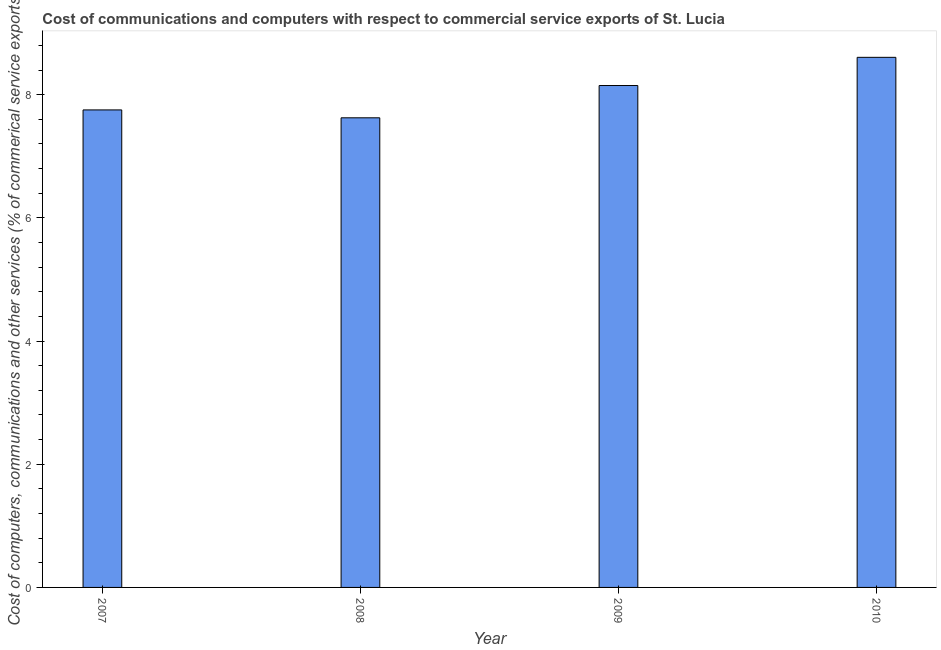What is the title of the graph?
Your answer should be very brief. Cost of communications and computers with respect to commercial service exports of St. Lucia. What is the label or title of the Y-axis?
Keep it short and to the point. Cost of computers, communications and other services (% of commerical service exports). What is the  computer and other services in 2008?
Your response must be concise. 7.63. Across all years, what is the maximum cost of communications?
Offer a terse response. 8.61. Across all years, what is the minimum  computer and other services?
Provide a short and direct response. 7.63. What is the sum of the  computer and other services?
Ensure brevity in your answer.  32.13. What is the difference between the cost of communications in 2008 and 2010?
Make the answer very short. -0.98. What is the average cost of communications per year?
Your answer should be compact. 8.03. What is the median cost of communications?
Make the answer very short. 7.95. In how many years, is the cost of communications greater than 3.6 %?
Keep it short and to the point. 4. What is the difference between the highest and the second highest cost of communications?
Offer a terse response. 0.46. In how many years, is the cost of communications greater than the average cost of communications taken over all years?
Ensure brevity in your answer.  2. How many bars are there?
Make the answer very short. 4. Are all the bars in the graph horizontal?
Ensure brevity in your answer.  No. What is the difference between two consecutive major ticks on the Y-axis?
Offer a terse response. 2. What is the Cost of computers, communications and other services (% of commerical service exports) of 2007?
Your response must be concise. 7.75. What is the Cost of computers, communications and other services (% of commerical service exports) in 2008?
Keep it short and to the point. 7.63. What is the Cost of computers, communications and other services (% of commerical service exports) in 2009?
Offer a terse response. 8.15. What is the Cost of computers, communications and other services (% of commerical service exports) of 2010?
Your answer should be compact. 8.61. What is the difference between the Cost of computers, communications and other services (% of commerical service exports) in 2007 and 2008?
Offer a very short reply. 0.13. What is the difference between the Cost of computers, communications and other services (% of commerical service exports) in 2007 and 2009?
Offer a very short reply. -0.4. What is the difference between the Cost of computers, communications and other services (% of commerical service exports) in 2007 and 2010?
Your answer should be compact. -0.85. What is the difference between the Cost of computers, communications and other services (% of commerical service exports) in 2008 and 2009?
Give a very brief answer. -0.52. What is the difference between the Cost of computers, communications and other services (% of commerical service exports) in 2008 and 2010?
Offer a terse response. -0.98. What is the difference between the Cost of computers, communications and other services (% of commerical service exports) in 2009 and 2010?
Make the answer very short. -0.46. What is the ratio of the Cost of computers, communications and other services (% of commerical service exports) in 2007 to that in 2009?
Offer a terse response. 0.95. What is the ratio of the Cost of computers, communications and other services (% of commerical service exports) in 2007 to that in 2010?
Your answer should be very brief. 0.9. What is the ratio of the Cost of computers, communications and other services (% of commerical service exports) in 2008 to that in 2009?
Ensure brevity in your answer.  0.94. What is the ratio of the Cost of computers, communications and other services (% of commerical service exports) in 2008 to that in 2010?
Your answer should be very brief. 0.89. What is the ratio of the Cost of computers, communications and other services (% of commerical service exports) in 2009 to that in 2010?
Ensure brevity in your answer.  0.95. 